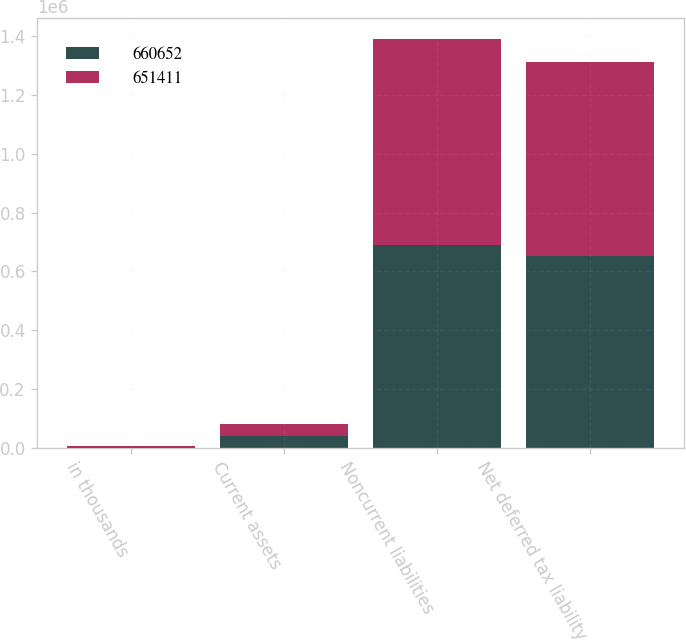<chart> <loc_0><loc_0><loc_500><loc_500><stacked_bar_chart><ecel><fcel>in thousands<fcel>Current assets<fcel>Noncurrent liabilities<fcel>Net deferred tax liability<nl><fcel>660652<fcel>2014<fcel>39726<fcel>691137<fcel>651411<nl><fcel>651411<fcel>2013<fcel>40423<fcel>701075<fcel>660652<nl></chart> 